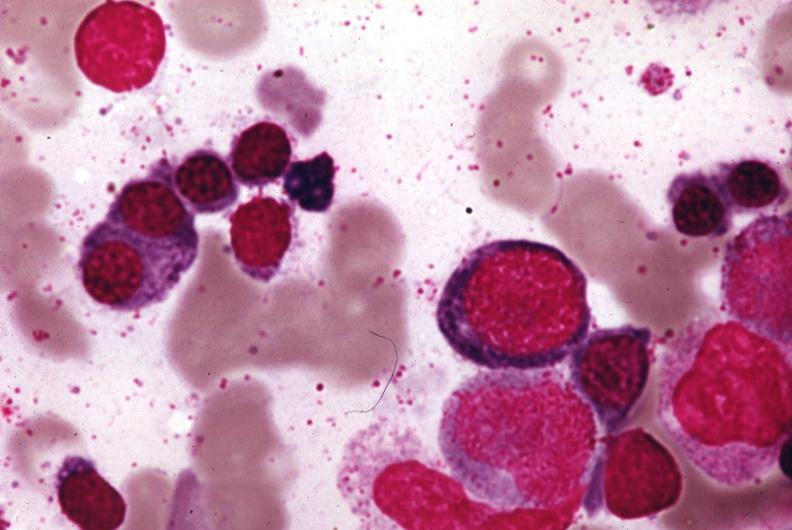does theca luteum cysts in newborn stain?
Answer the question using a single word or phrase. No 